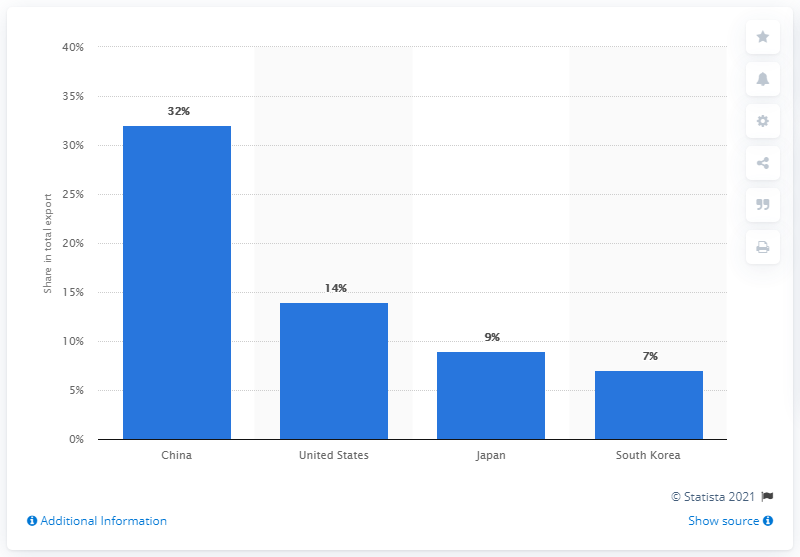Highlight a few significant elements in this photo. In 2019, China was Chile's most significant export partner, accounting for a significant portion of the country's overall exports. 